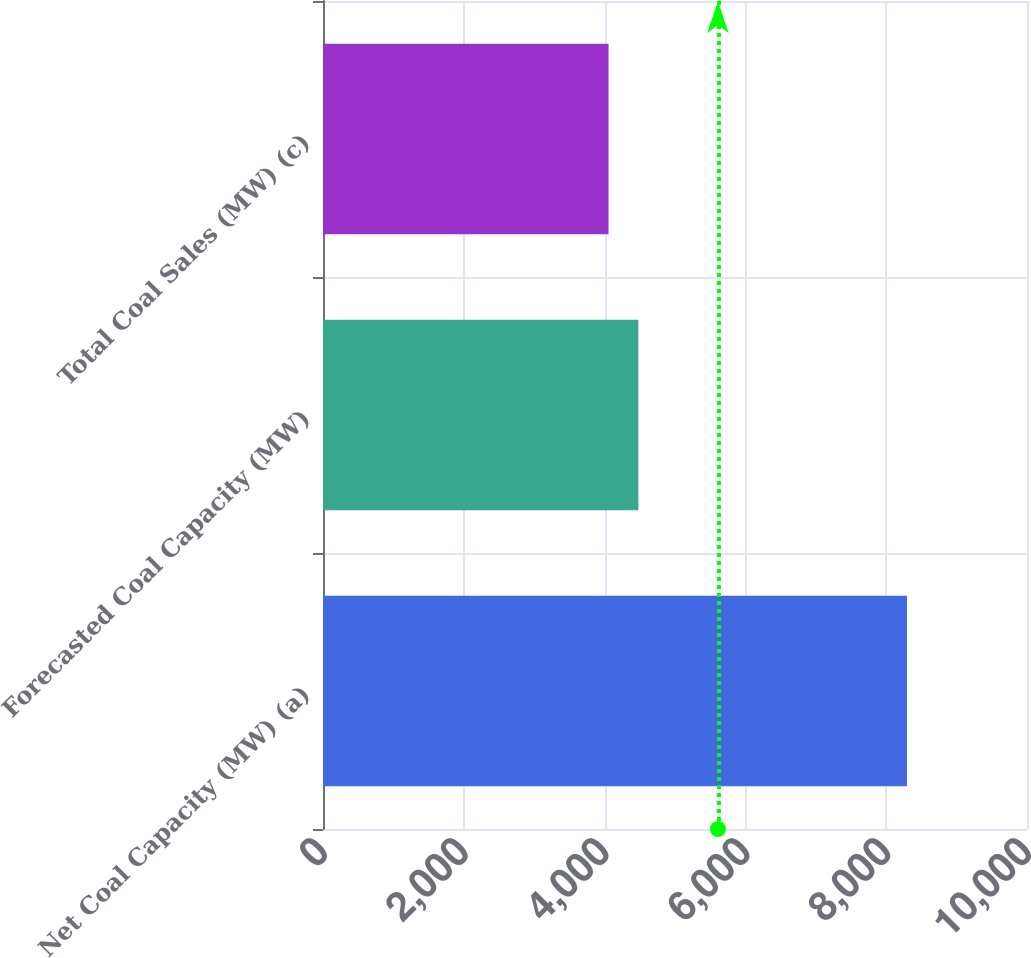Convert chart to OTSL. <chart><loc_0><loc_0><loc_500><loc_500><bar_chart><fcel>Net Coal Capacity (MW) (a)<fcel>Forecasted Coal Capacity (MW)<fcel>Total Coal Sales (MW) (c)<nl><fcel>8295<fcel>4479.9<fcel>4056<nl></chart> 